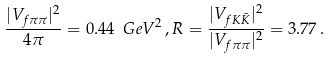<formula> <loc_0><loc_0><loc_500><loc_500>\frac { | V _ { f \pi \pi } | ^ { 2 } } { 4 \pi } = 0 . 4 4 \ G e V ^ { 2 } \, , R = \frac { | V _ { f K \bar { K } } | ^ { 2 } } { | V _ { f \pi \pi } | ^ { 2 } } = 3 . 7 7 \, .</formula> 